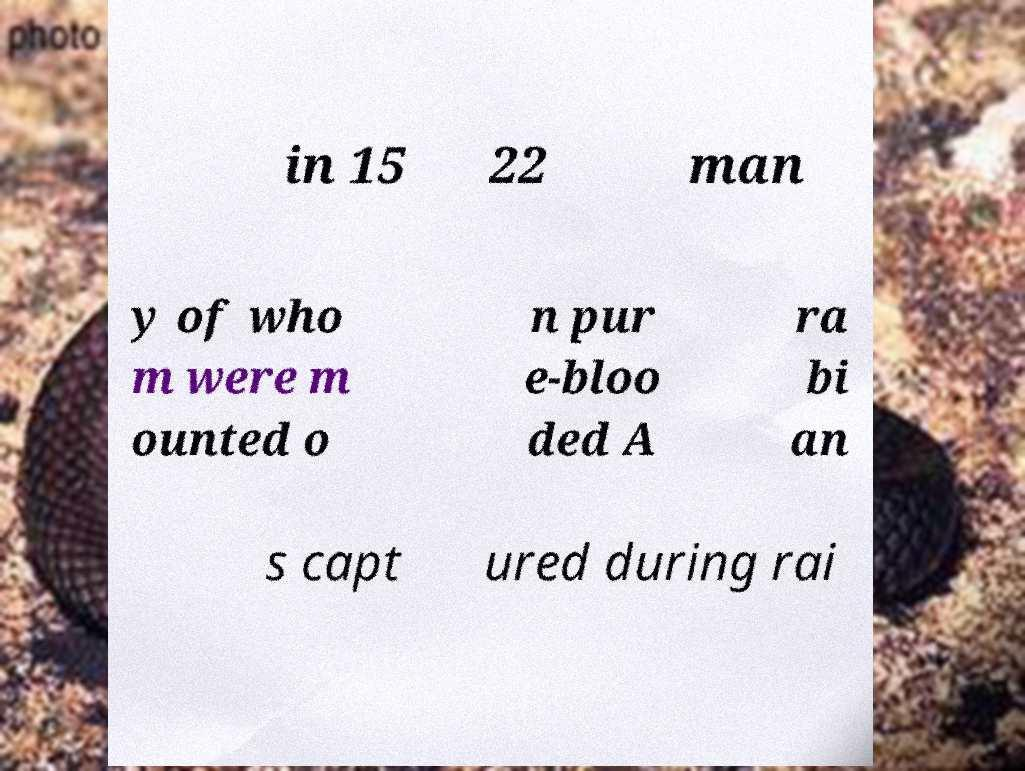What messages or text are displayed in this image? I need them in a readable, typed format. in 15 22 man y of who m were m ounted o n pur e-bloo ded A ra bi an s capt ured during rai 